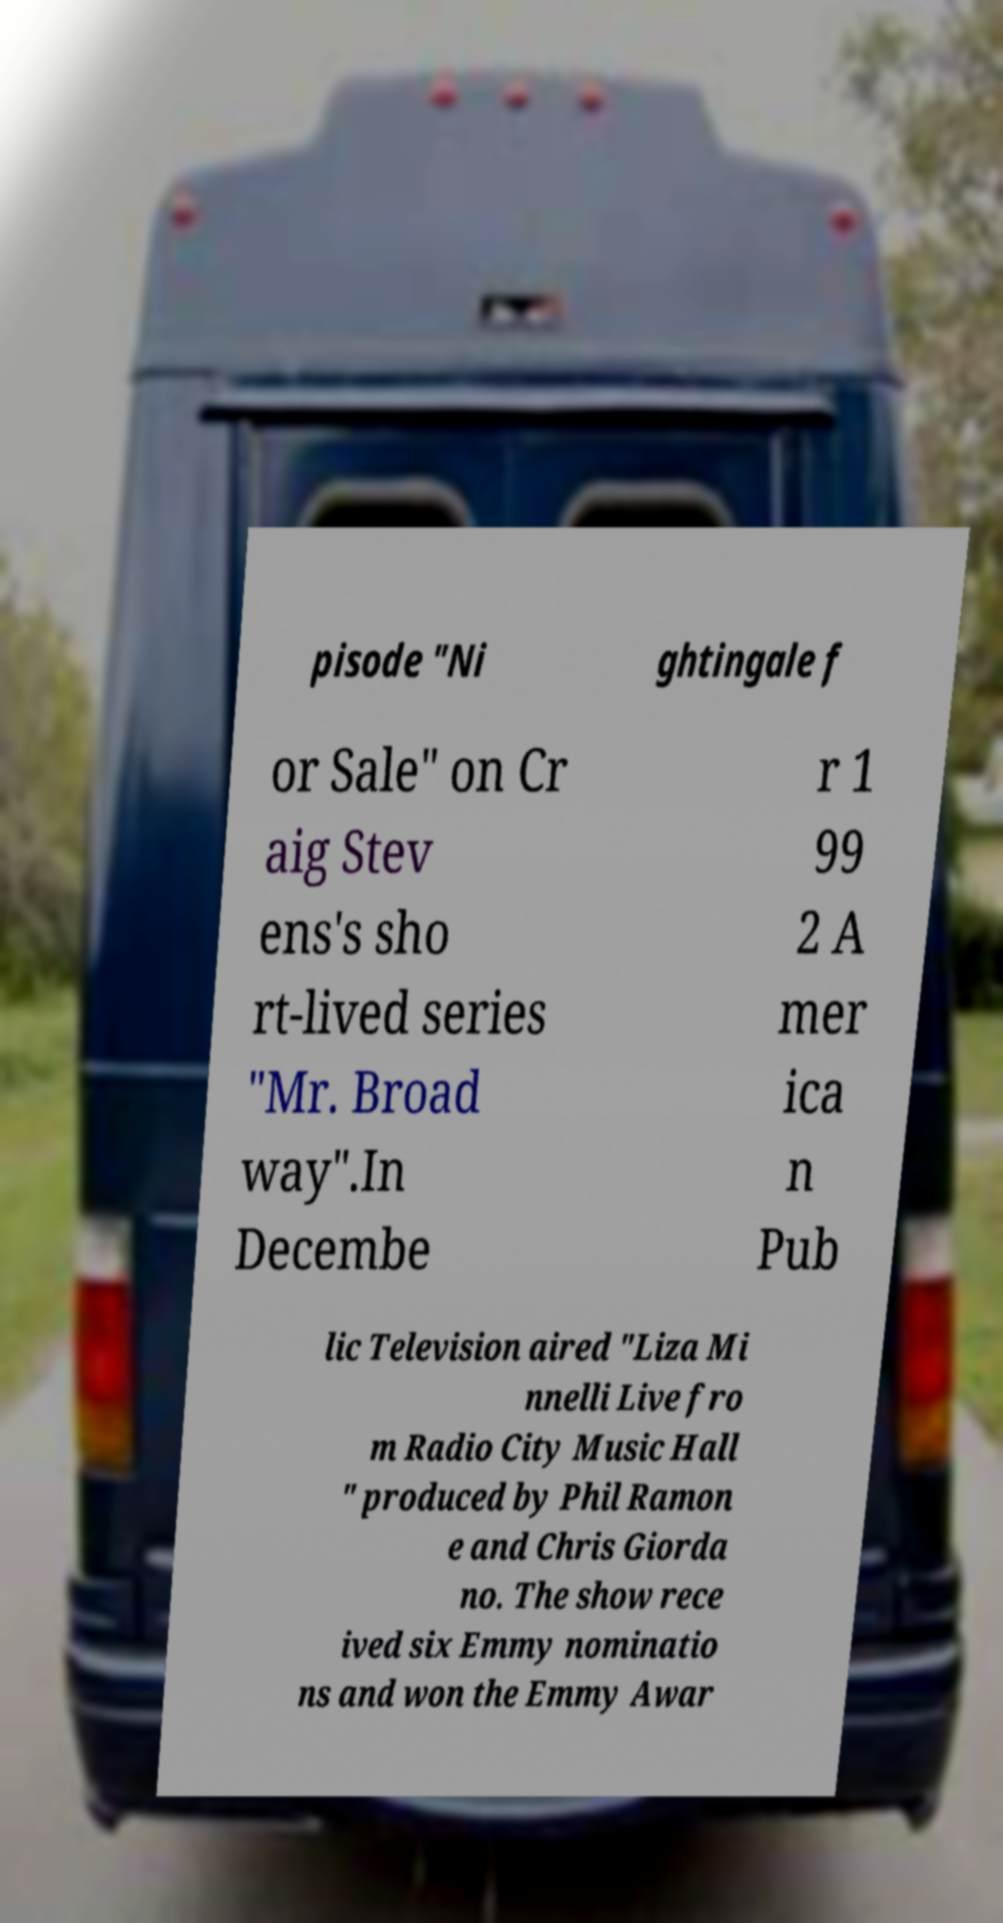Can you read and provide the text displayed in the image?This photo seems to have some interesting text. Can you extract and type it out for me? pisode "Ni ghtingale f or Sale" on Cr aig Stev ens's sho rt-lived series "Mr. Broad way".In Decembe r 1 99 2 A mer ica n Pub lic Television aired "Liza Mi nnelli Live fro m Radio City Music Hall " produced by Phil Ramon e and Chris Giorda no. The show rece ived six Emmy nominatio ns and won the Emmy Awar 